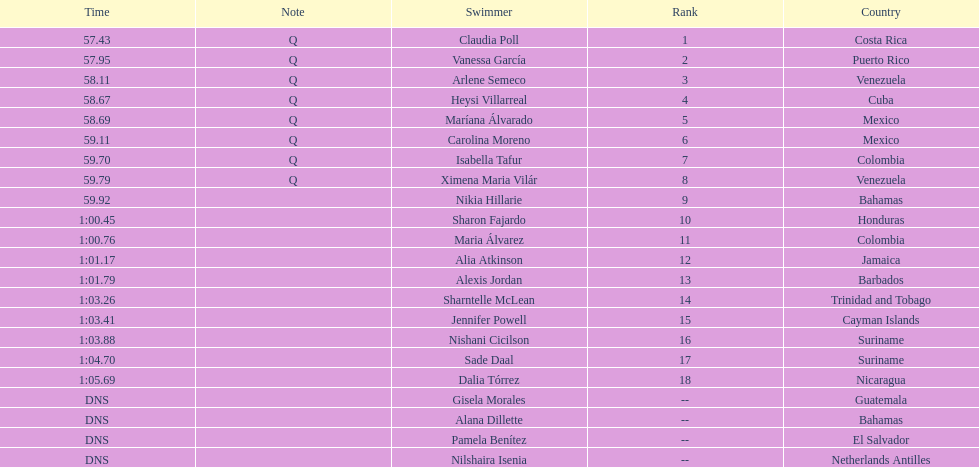Which swimmer had the most extended duration? Dalia Tórrez. 